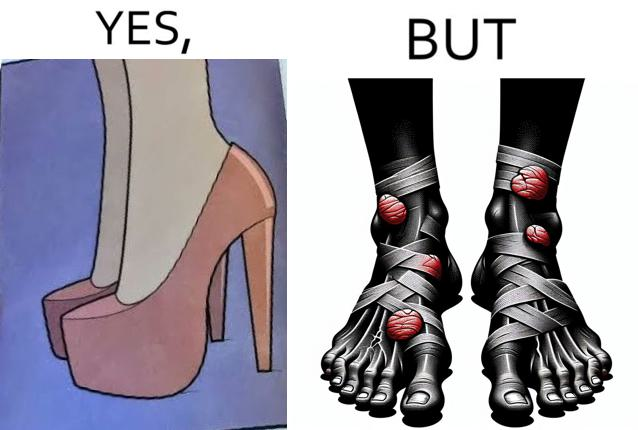Describe what you see in the left and right parts of this image. In the left part of the image: a pair of high heeled shoes In the right part of the image: A pair of feet, blistered and red, with bandages 